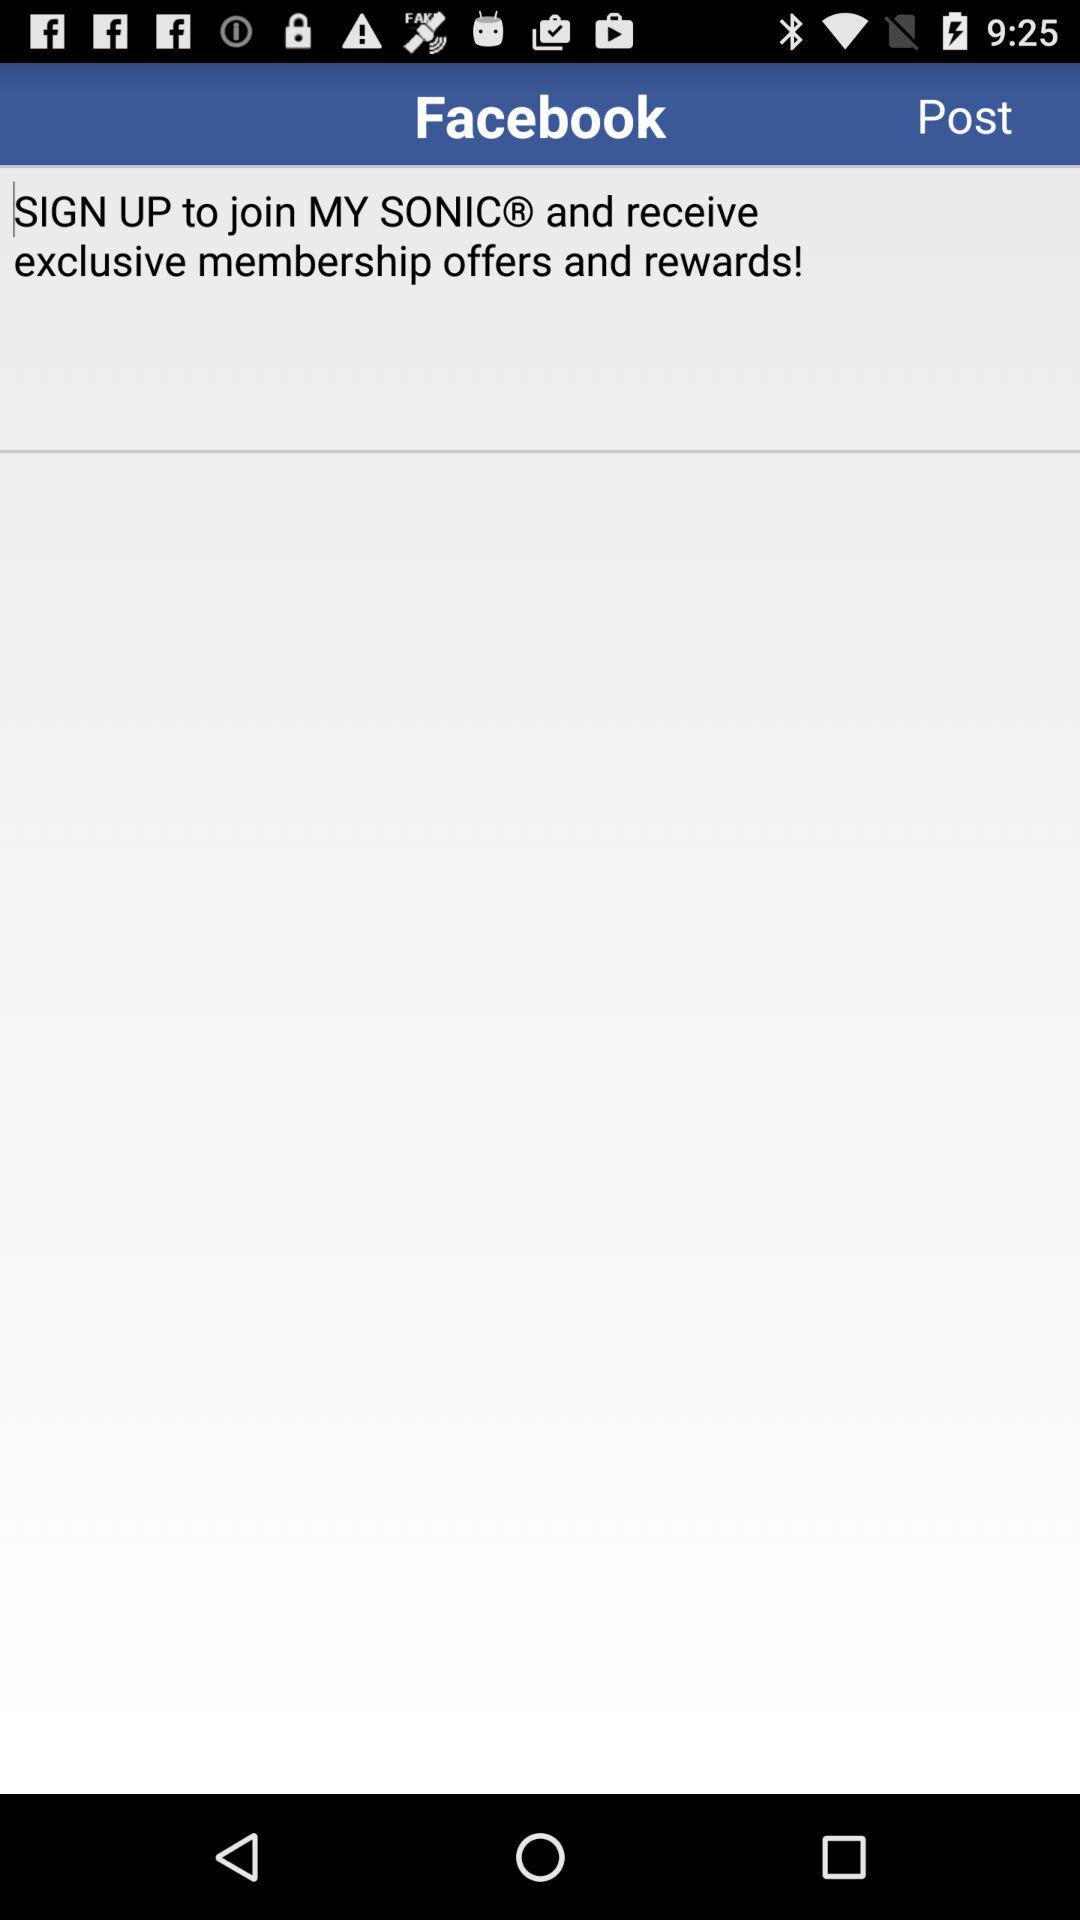What is the name of application? The name of application is "Facebook ". 